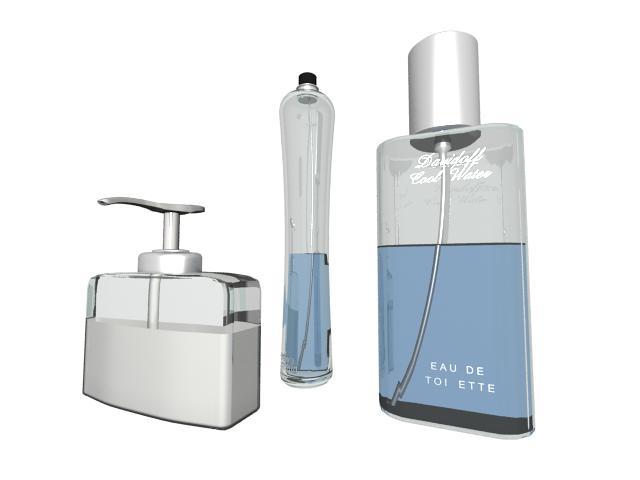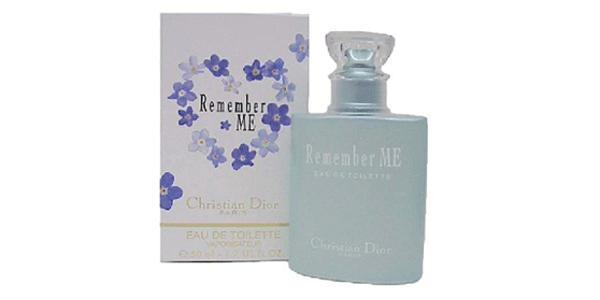The first image is the image on the left, the second image is the image on the right. Evaluate the accuracy of this statement regarding the images: "There are at most two bottles of perfume.". Is it true? Answer yes or no. No. The first image is the image on the left, the second image is the image on the right. Analyze the images presented: Is the assertion "There are four perfume bottles in both images." valid? Answer yes or no. No. 